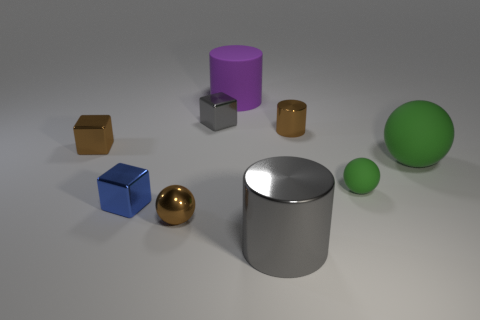What size is the gray shiny thing that is to the right of the rubber thing that is behind the shiny cylinder that is behind the large gray object?
Ensure brevity in your answer.  Large. Are there any small spheres that are behind the big object that is to the right of the big gray shiny thing?
Your answer should be very brief. No. Do the tiny green rubber object and the tiny brown metallic thing that is in front of the small blue cube have the same shape?
Your response must be concise. Yes. There is a matte sphere that is left of the big sphere; what is its color?
Ensure brevity in your answer.  Green. There is a brown metal thing that is on the left side of the brown thing in front of the tiny rubber sphere; what is its size?
Provide a short and direct response. Small. Does the large rubber object on the right side of the tiny rubber ball have the same shape as the small blue shiny object?
Make the answer very short. No. There is a gray thing that is the same shape as the blue object; what is its material?
Your answer should be very brief. Metal. How many things are either objects behind the large gray metallic cylinder or rubber cylinders behind the gray cube?
Your answer should be very brief. 8. Does the large ball have the same color as the tiny block to the right of the tiny metallic ball?
Your response must be concise. No. What is the shape of the large gray object that is the same material as the small cylinder?
Offer a terse response. Cylinder. 